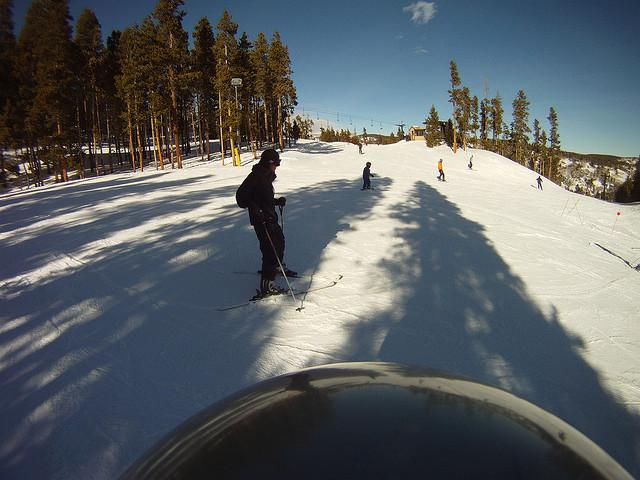What surrounds these people?

Choices:
A) sand
B) mud
C) ocean
D) mountains mountains 